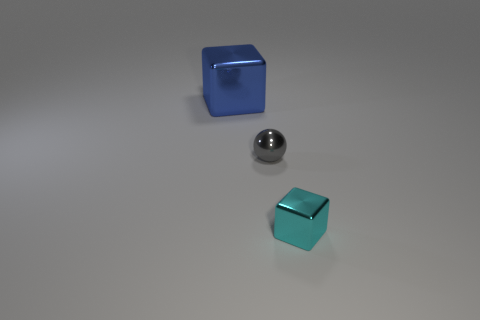Add 3 blue cubes. How many objects exist? 6 Subtract all blue blocks. How many blocks are left? 1 Subtract 1 spheres. How many spheres are left? 0 Add 1 blue things. How many blue things are left? 2 Add 1 yellow shiny balls. How many yellow shiny balls exist? 1 Subtract 0 green blocks. How many objects are left? 3 Subtract all cubes. How many objects are left? 1 Subtract all brown spheres. Subtract all brown cylinders. How many spheres are left? 1 Subtract all brown cylinders. How many yellow cubes are left? 0 Subtract all tiny cyan blocks. Subtract all small gray objects. How many objects are left? 1 